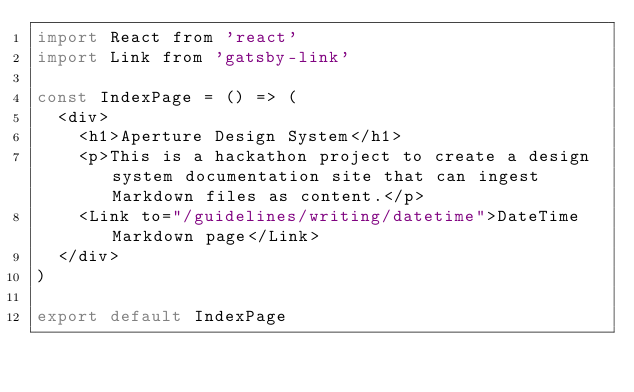Convert code to text. <code><loc_0><loc_0><loc_500><loc_500><_JavaScript_>import React from 'react'
import Link from 'gatsby-link'

const IndexPage = () => (
  <div>
    <h1>Aperture Design System</h1>
    <p>This is a hackathon project to create a design system documentation site that can ingest Markdown files as content.</p>
    <Link to="/guidelines/writing/datetime">DateTime Markdown page</Link>
  </div>
)

export default IndexPage
</code> 